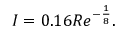Convert formula to latex. <formula><loc_0><loc_0><loc_500><loc_500>I = 0 . 1 6 R e ^ { - { \frac { 1 } { 8 } } } .</formula> 